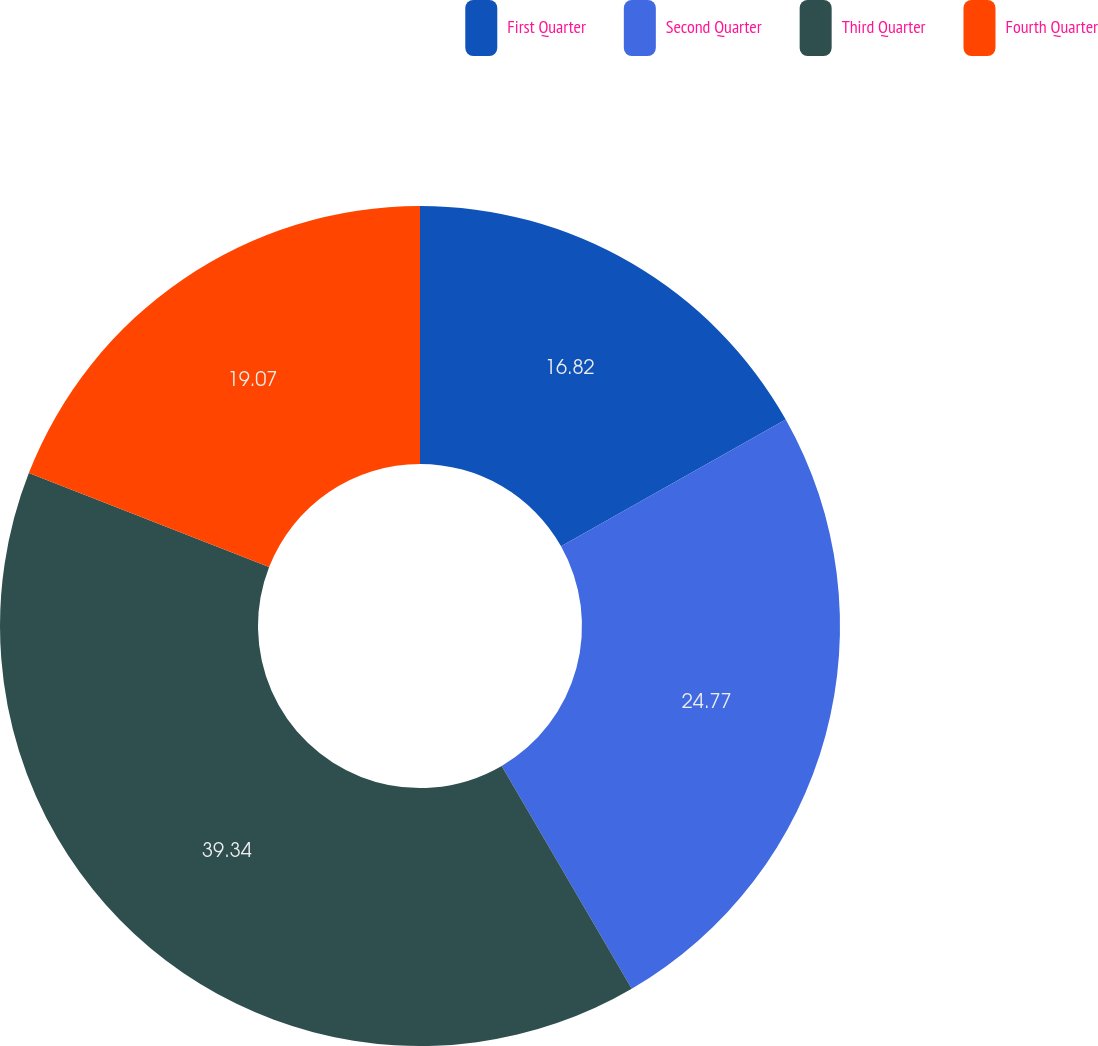<chart> <loc_0><loc_0><loc_500><loc_500><pie_chart><fcel>First Quarter<fcel>Second Quarter<fcel>Third Quarter<fcel>Fourth Quarter<nl><fcel>16.82%<fcel>24.77%<fcel>39.34%<fcel>19.07%<nl></chart> 